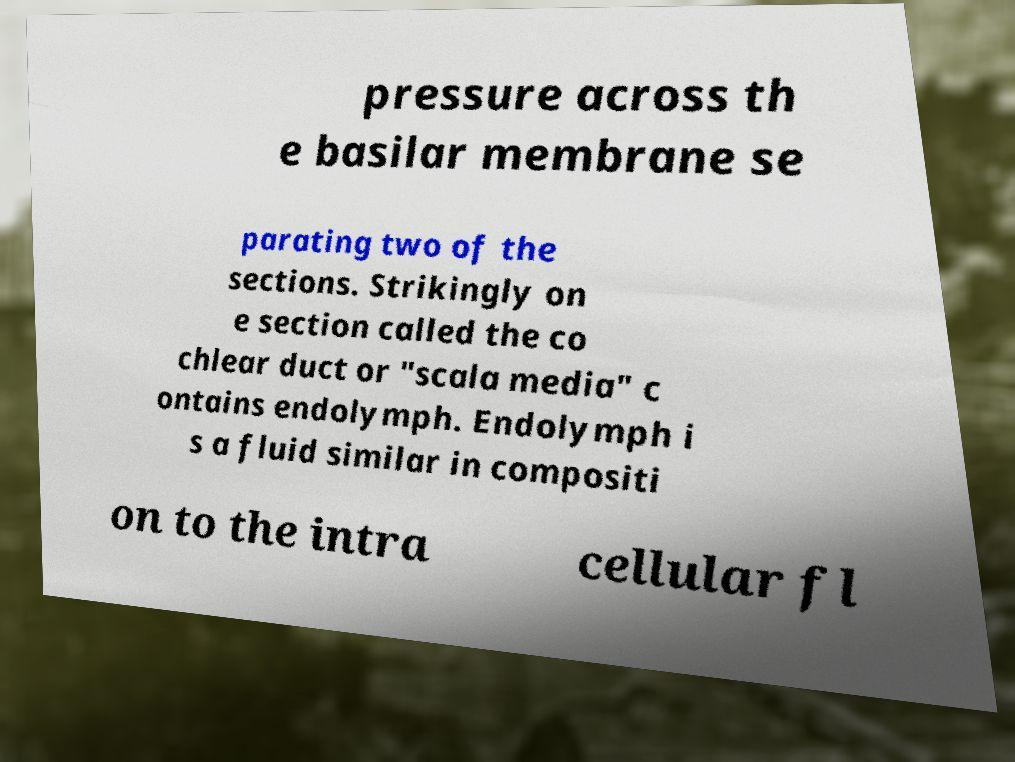Can you accurately transcribe the text from the provided image for me? pressure across th e basilar membrane se parating two of the sections. Strikingly on e section called the co chlear duct or "scala media" c ontains endolymph. Endolymph i s a fluid similar in compositi on to the intra cellular fl 